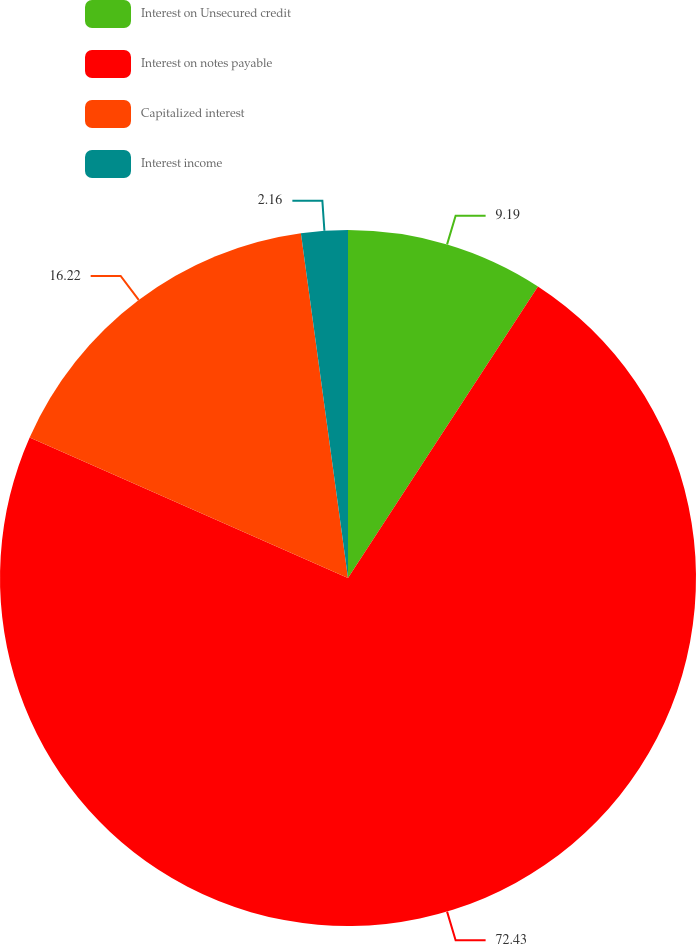Convert chart. <chart><loc_0><loc_0><loc_500><loc_500><pie_chart><fcel>Interest on Unsecured credit<fcel>Interest on notes payable<fcel>Capitalized interest<fcel>Interest income<nl><fcel>9.19%<fcel>72.43%<fcel>16.22%<fcel>2.16%<nl></chart> 